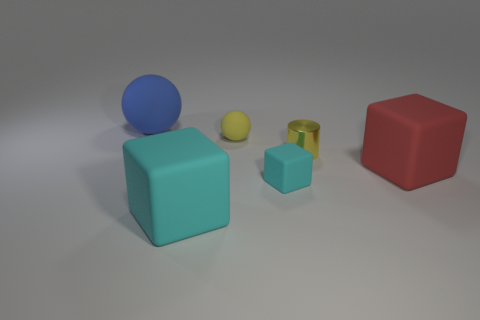Subtract all cyan cylinders. How many cyan blocks are left? 2 Subtract all red cubes. How many cubes are left? 2 Add 2 purple things. How many objects exist? 8 Subtract 1 red blocks. How many objects are left? 5 Subtract all cylinders. How many objects are left? 5 Subtract all small yellow rubber cylinders. Subtract all small cyan matte blocks. How many objects are left? 5 Add 2 blue things. How many blue things are left? 3 Add 2 gray metallic cubes. How many gray metallic cubes exist? 2 